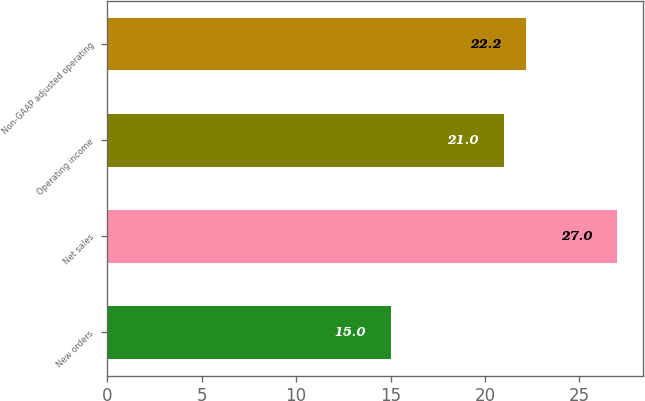<chart> <loc_0><loc_0><loc_500><loc_500><bar_chart><fcel>New orders<fcel>Net sales<fcel>Operating income<fcel>Non-GAAP adjusted operating<nl><fcel>15<fcel>27<fcel>21<fcel>22.2<nl></chart> 